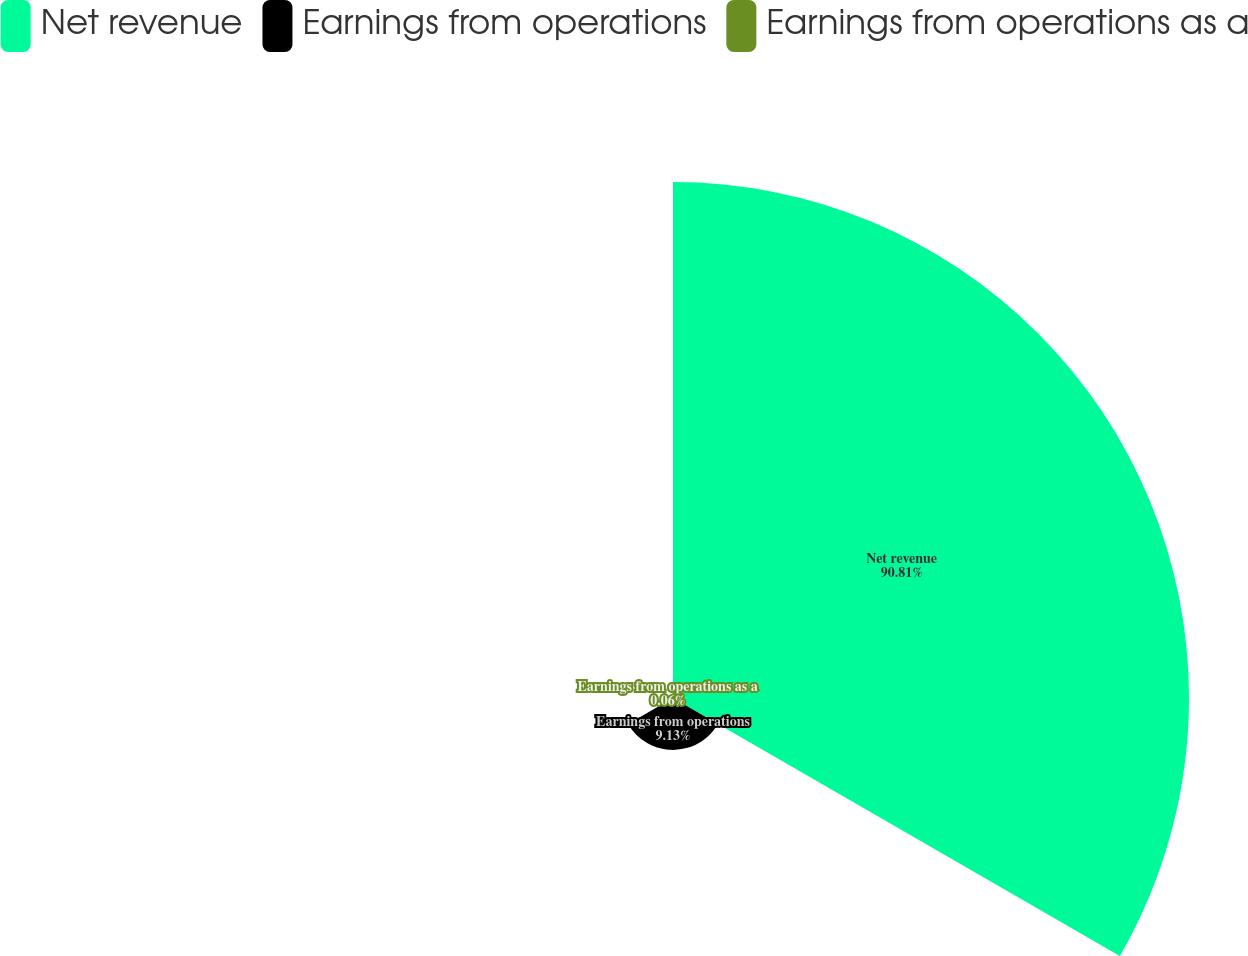<chart> <loc_0><loc_0><loc_500><loc_500><pie_chart><fcel>Net revenue<fcel>Earnings from operations<fcel>Earnings from operations as a<nl><fcel>90.81%<fcel>9.13%<fcel>0.06%<nl></chart> 